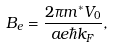<formula> <loc_0><loc_0><loc_500><loc_500>B _ { e } = \frac { 2 \pi m ^ { * } V _ { 0 } } { a e \hbar { k } _ { F } } ,</formula> 